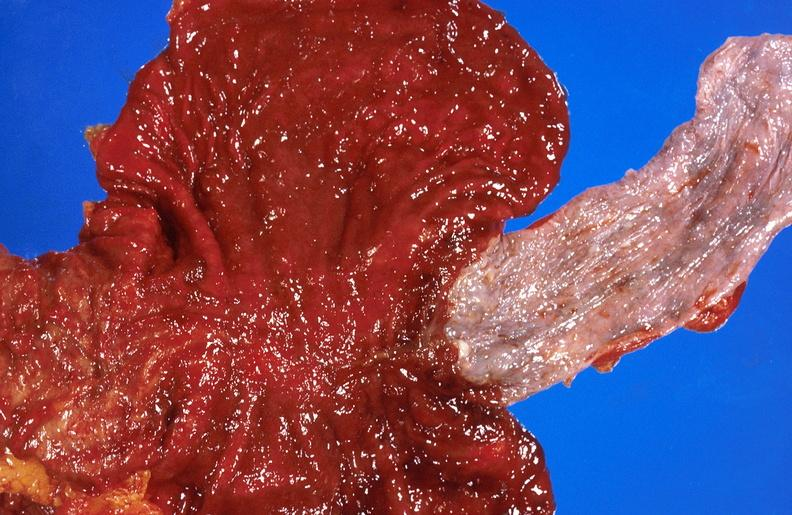s hepatobiliary present?
Answer the question using a single word or phrase. Yes 